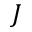<formula> <loc_0><loc_0><loc_500><loc_500>J</formula> 